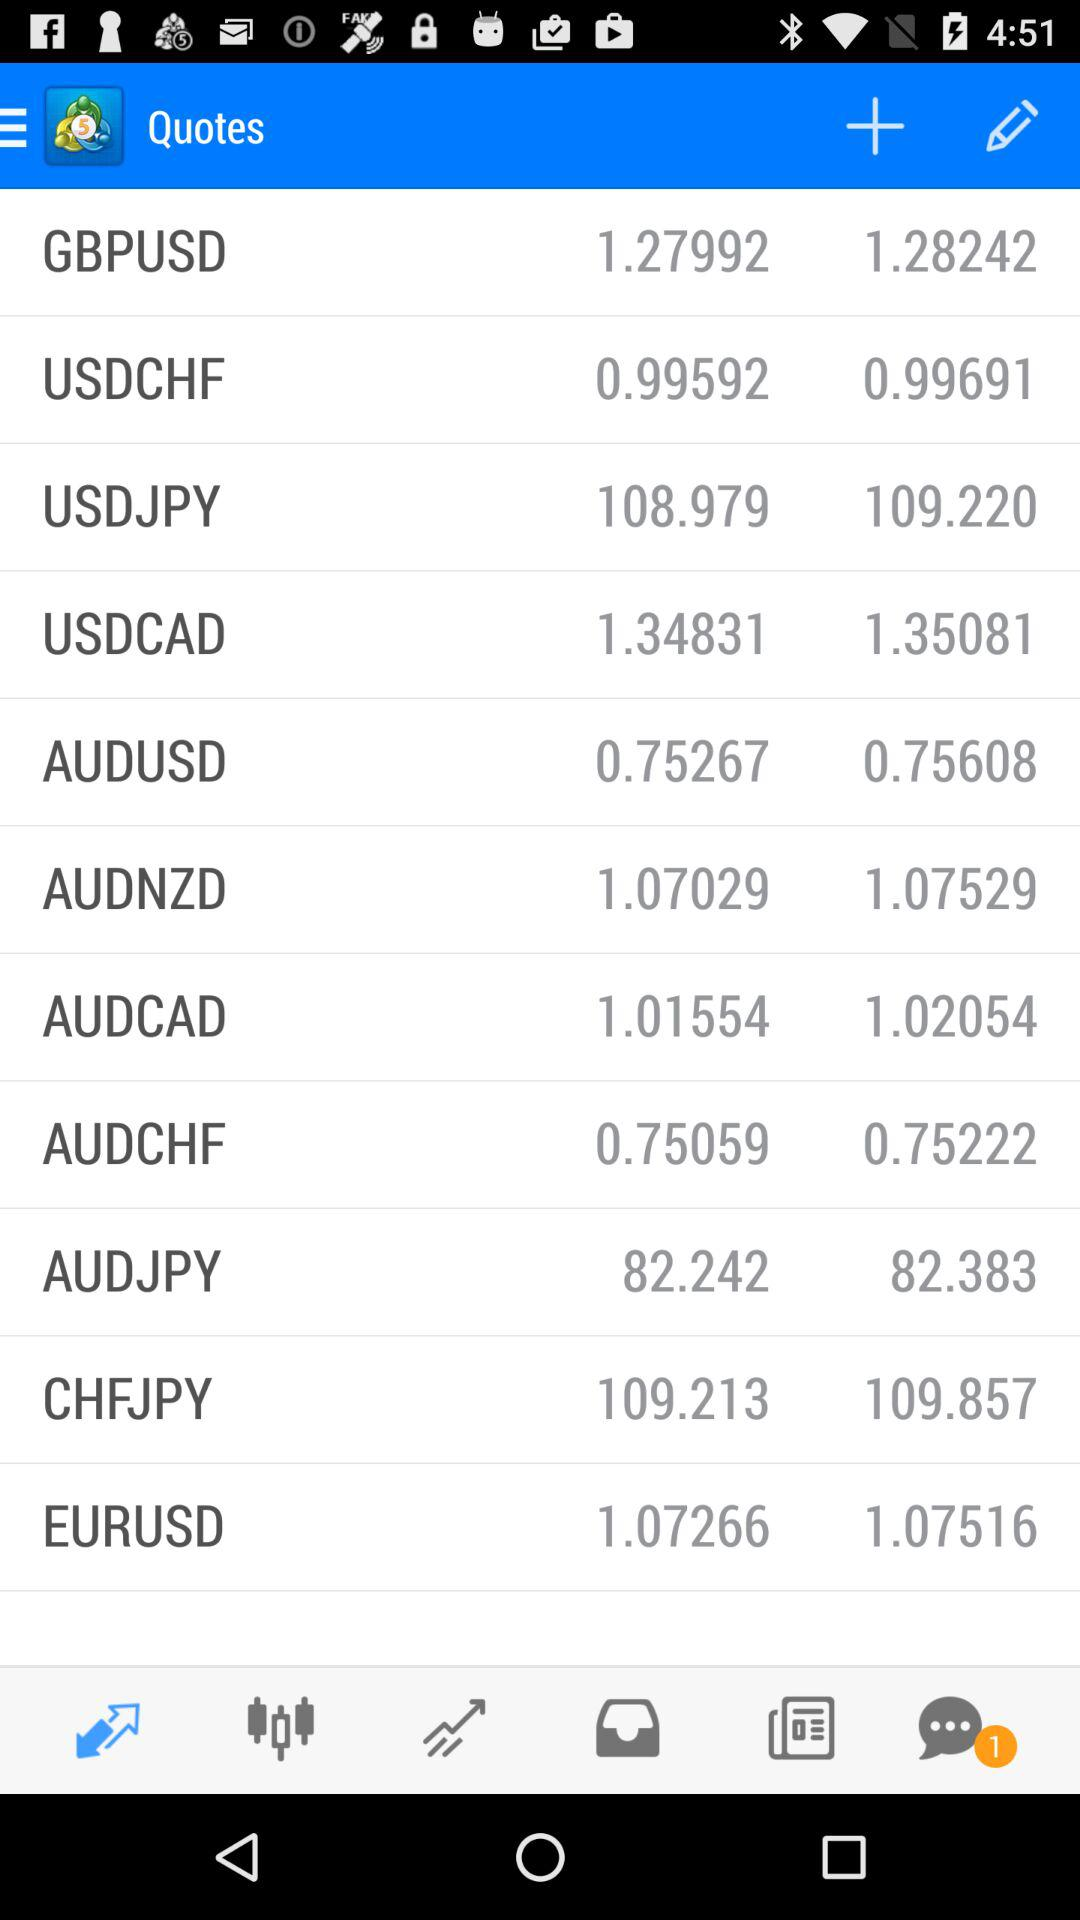How many unread chats are there? There is 1 unread chat. 